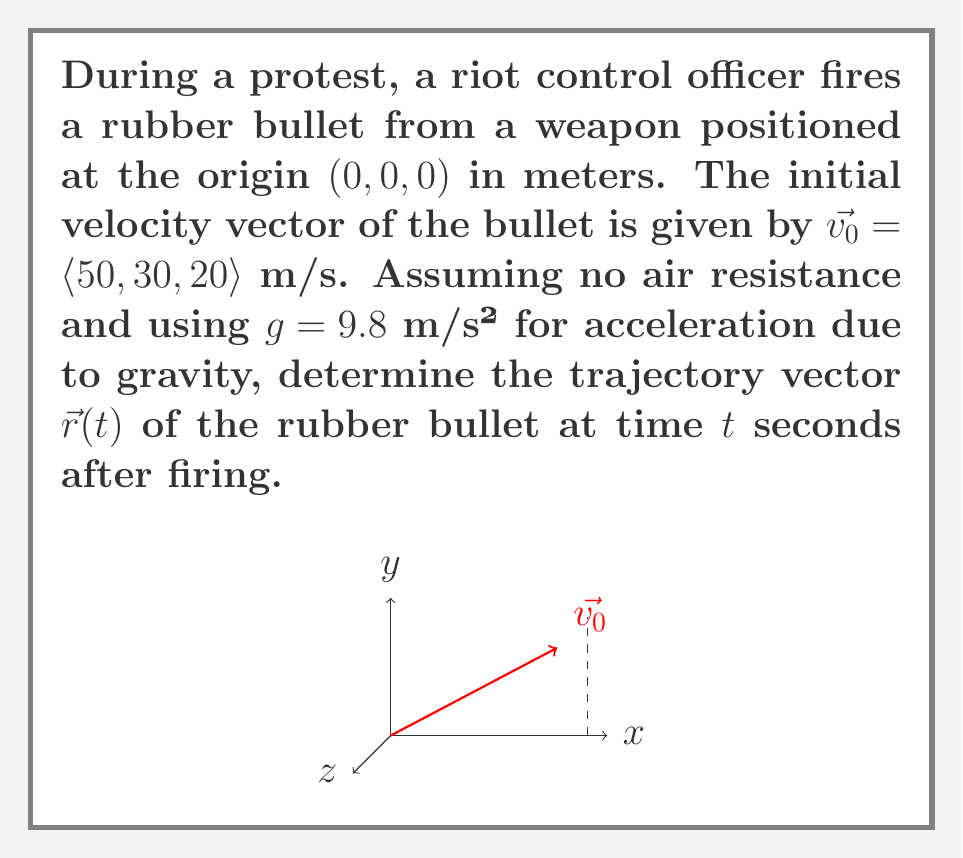Help me with this question. To find the trajectory vector $\vec{r}(t)$, we need to consider the motion in each dimension separately:

1) In the x-direction:
   There's no acceleration, so $x(t) = x_0 + v_{x0}t$
   $x(t) = 0 + 50t$

2) In the y-direction:
   There's no acceleration, so $y(t) = y_0 + v_{y0}t$
   $y(t) = 0 + 30t$

3) In the z-direction:
   There's acceleration due to gravity, so we use $z(t) = z_0 + v_{z0}t - \frac{1}{2}gt^2$
   $z(t) = 0 + 20t - \frac{1}{2}(9.8)t^2$

Now, we can combine these components into a vector equation:

$$\vec{r}(t) = \langle x(t), y(t), z(t) \rangle$$

Substituting our expressions:

$$\vec{r}(t) = \langle 50t, 30t, 20t - 4.9t^2 \rangle$$

This vector equation describes the position of the rubber bullet at any time $t$ after it's fired, ignoring air resistance.
Answer: $\vec{r}(t) = \langle 50t, 30t, 20t - 4.9t^2 \rangle$ m 